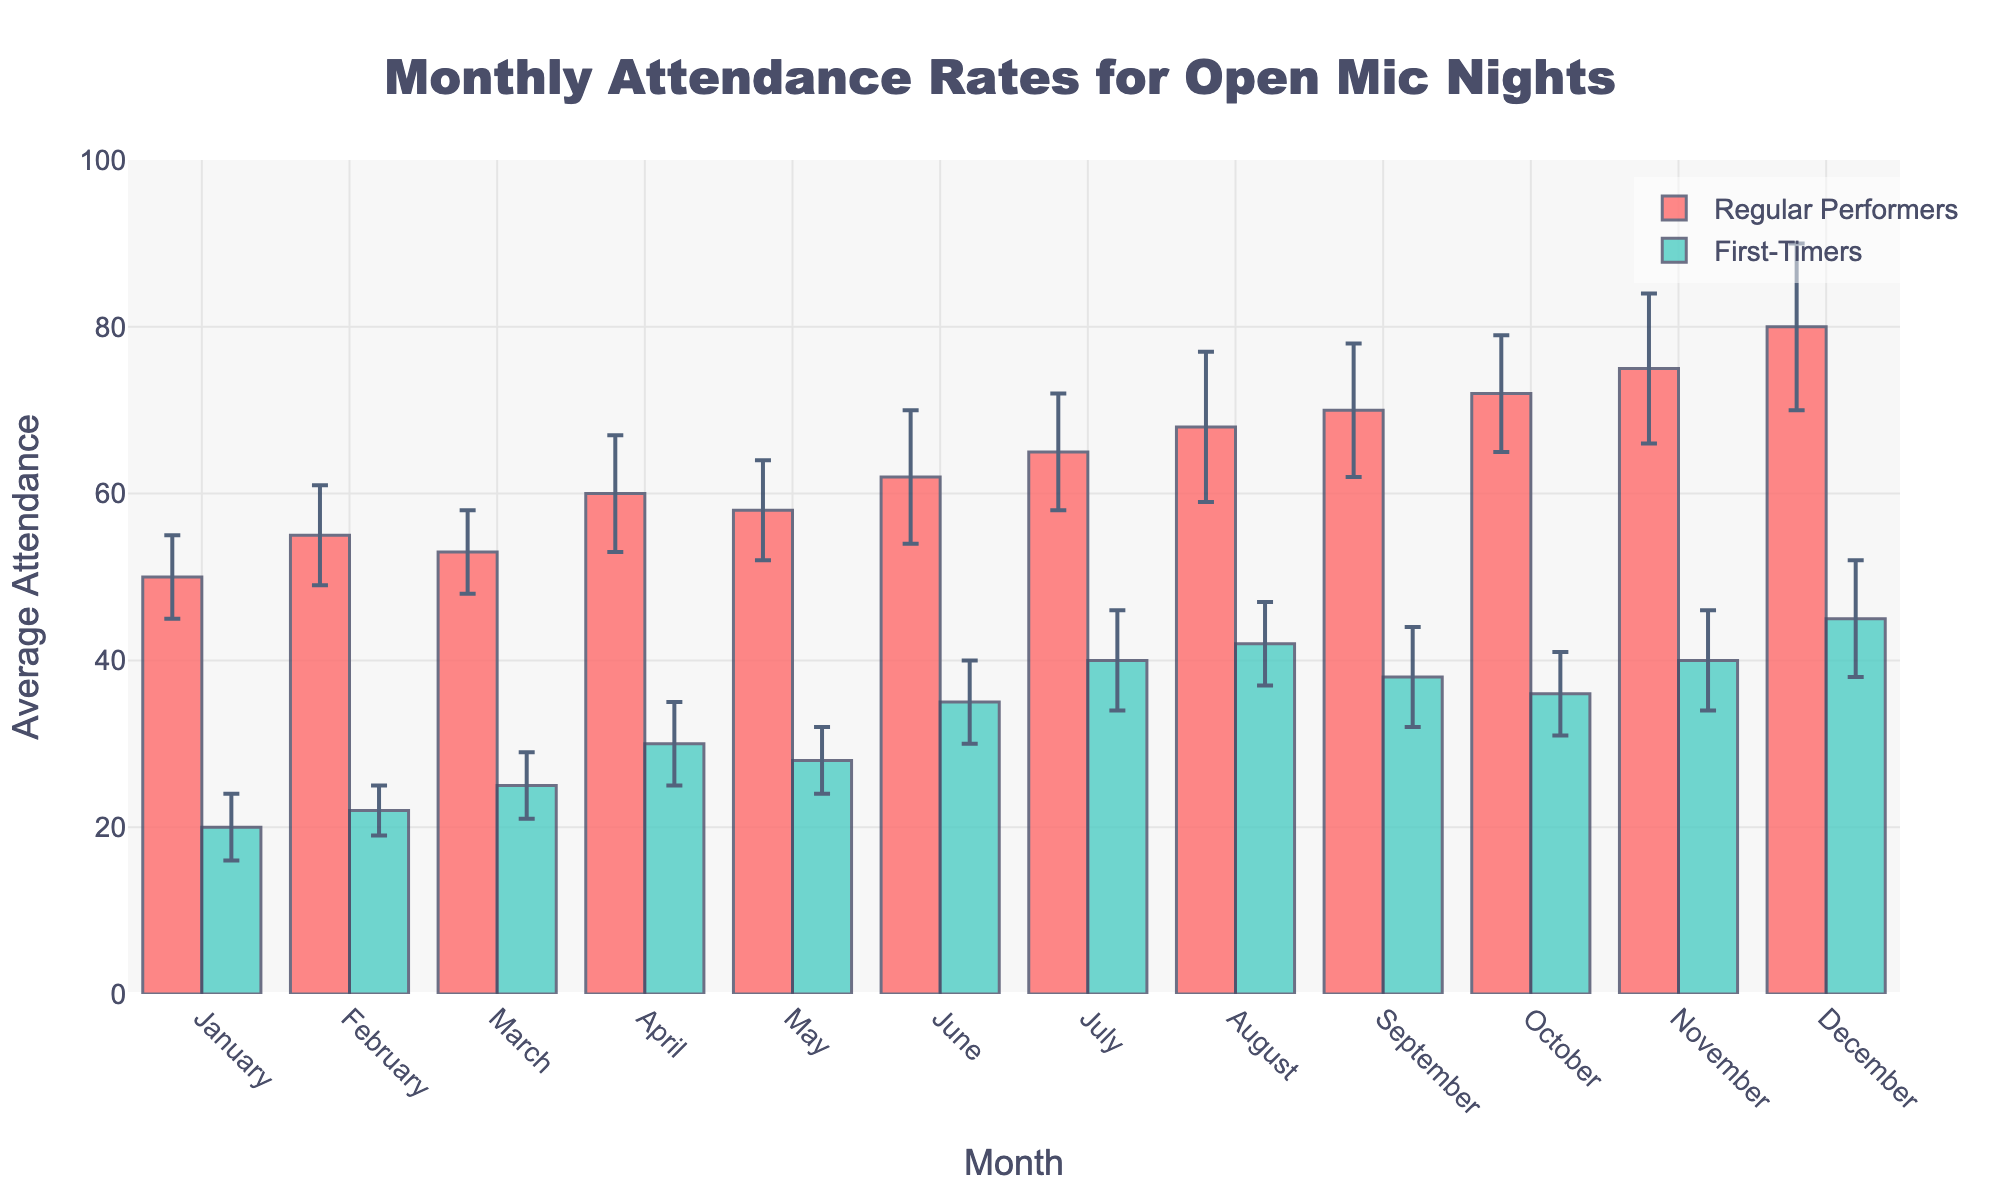What is the title of the bar chart? The title is displayed at the top center of the chart in large, bold font.
Answer: Monthly Attendance Rates for Open Mic Nights What is the average attendance for Regular Performers in April? Look at the bar corresponding to Regular Performers in April and read the y-axis value.
Answer: 60 Which month had the highest average attendance for First-Timers? Compare the heights of the First-Timers bars across all months and identify the one with the highest bar.
Answer: December In which month is the gap between average attendance for Regular Performers and First-Timers the largest? Calculate the difference between the bars of Regular Performers and First-Timers for each month, and find the month with the biggest difference.
Answer: December What is the color of the bars representing Regular Performers? Look at the legend for "Regular Performers" to see the bar color.
Answer: Red What is the average attendance for Regular Performers and First-Timers combined in February? Sum the average attendance for Regular Performers (55) and First-Timers (22) for February: 55 + 22.
Answer: 77 What is the main difference in error bars between Regular Performers and First-Timers in June? Compare the lengths of the error bars on top of the bars for June.
Answer: Regular Performers have longer error bars How does the average attendance for First-Timers in October compare to the average attendance in September? Compare the heights of the First-Timers bars between October and September.
Answer: October is lower than September In which month do Regular Performers have the smallest error bars? Observe and compare the lengths of error bars for the Regular Performers across all months to find the smallest.
Answer: January How does the regular attendance in July compare to the regular attendance in March? Compare the heights of the Regular Performers bars for July and March.
Answer: July is higher than March 